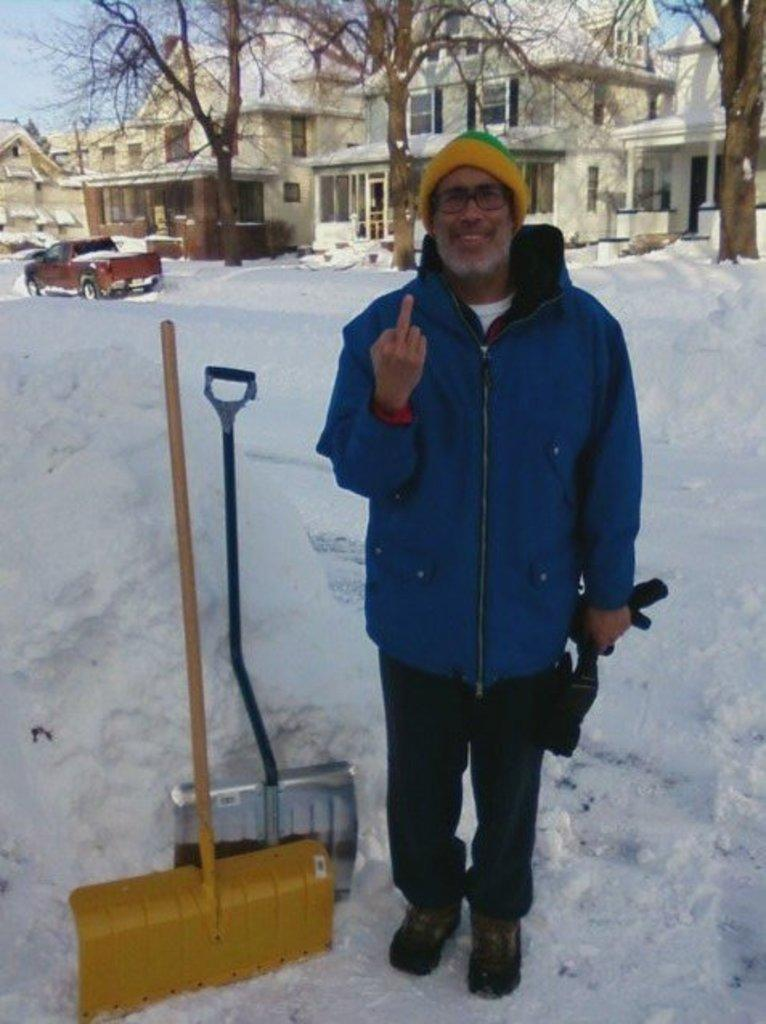Who is present in the image? There is a man in the image. What is the man wearing? The man is wearing a jacket, a cap, and spectacles. What is the man standing on? The man is standing on snow. What tools are visible in the image? There are spades in the image. What type of vehicle is in the image? There is a car in the image. What type of natural elements are present in the image? There are trees in the image. What type of structures are present in the image? There are buildings with windows in the image. What can be seen in the background of the image? The sky is visible in the background of the image. What type of attraction is the man visiting in the image? There is no indication of an attraction in the image; it simply shows a man standing on snow with a car, trees, and buildings in the background. 